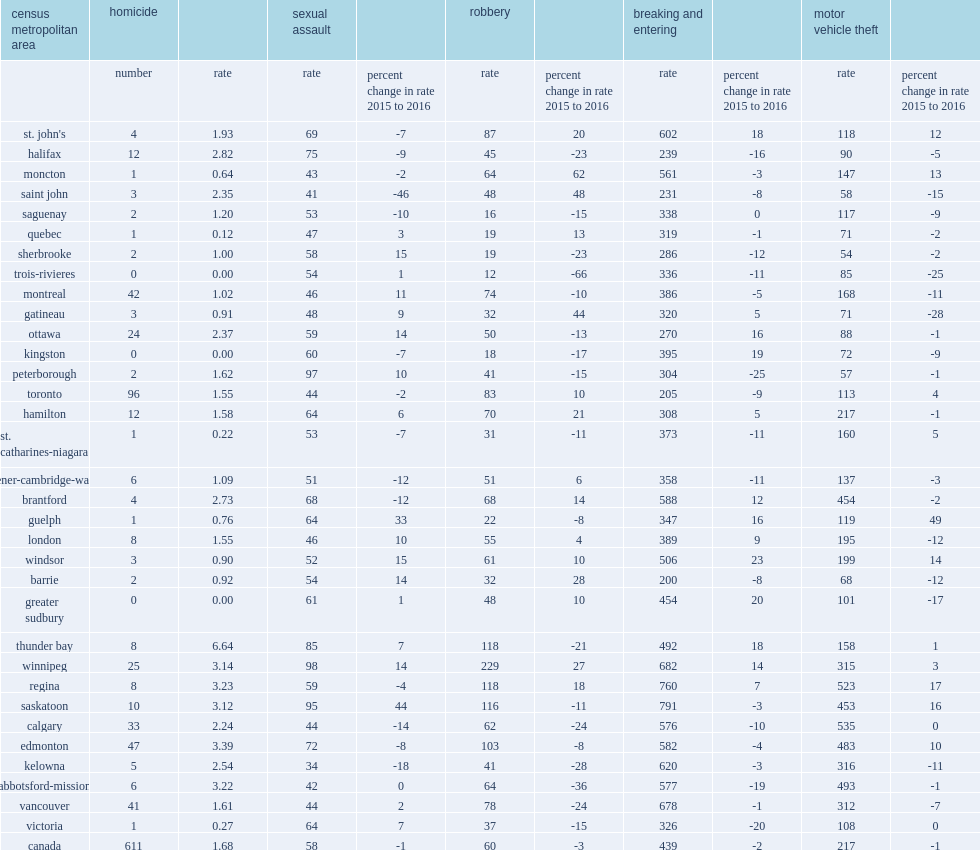How many homicides was recorded in thunder bay in 2016? 8.0. What is the recorded per 100,000 population homicide rate in thunder bay in 2016? 6.64. How many homicides was recorded in edmonton in 2016? 47.0. How many homicides was recorded in regina in 2016? 8.0. What is the recorded per 100,000 population homicide rate in edmonton? 3.39. What is the recorded per 100,000 population homicide rate in regina? 3.23. In 2016, how many homicides were reported in trois-rivieres? 0.0. In 2016, how many homicides were reported in kingston? 0.0. In 2016, how many homicides were reported in greater sudbury? 0.0. Comparing to 2015,how many percentage point of robbery rates has increased in moncton in 2016? 62.0. Comparing to 2015,how many percentage point of robbery rates has increased in saint john in 2016? 48.0. Comparing to 2015,how many percentage point of robbery rates has increased in gatineau in 2016? 44.0. Comparing to 2015,how many percentage point of robbery rates has increased in barrie in 2016? 28.0. Comparing to 2015,how many percentage point of the rate of robbery has trois-rivieres reported to decline in 2016? 66. What is the recported per 100,000 population robbery rate in trois-rivieres? 12.0. What is the recported per 100,000 population robbery rate in saguenay? 16.0. What is the recported per 100,000 population robbery rate in kingston? 18.0. What is the recported per 100,000 population robbery rate in quebec? 19.0. What is the recported per 100,000 population robbery rate in sherbrooke? 19.0. What is the recported per 100,000 population robbery rate in winnipeg? 229.0. Comparing to 2015,how many percentage point has winnipeg incresed in the rate of robbery in 2016? 27.0. Comparing to 2015,how many percentage point has gatineau reported to declines in motor vehicle theft in 2016? 28. Comparing to 2015,how many percentage point has trois-rivieres reported to declines in motor vehicle theft in 2016? 25. Comparing to 2015,how many percentage point has greater sudbury reported to declines in motor vehicle theft in 2016? 17. Comparing to 2015,how many percentage point has guelph reported to increases in motor vehicle theft in 2016? 49.0. Comparing to 2015,how many percentage point has regina reported to increases in motor vehicle theft in 2016? 17.0. Comparing to 2015,how many percentage point has saskatoon reported to increases in motor vehicle theft in 2016? 16.0. Comparing to 2015,how many percentage point has calgary reported to increases in motor vehicle theft in 2016? 0.0. Comparing to 2015,how many percentage point has edmonton reported to increases in motor vehicle theft in 2016? 10.0. 